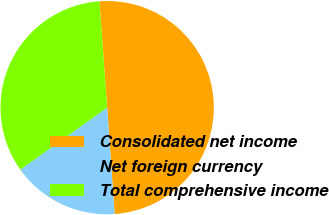Convert chart to OTSL. <chart><loc_0><loc_0><loc_500><loc_500><pie_chart><fcel>Consolidated net income<fcel>Net foreign currency<fcel>Total comprehensive income<nl><fcel>50.05%<fcel>16.24%<fcel>33.71%<nl></chart> 